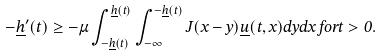Convert formula to latex. <formula><loc_0><loc_0><loc_500><loc_500>- \underline { h } ^ { \prime } ( t ) \geq - \mu \int _ { - \underline { h } ( t ) } ^ { \underline { h } ( t ) } \int _ { - \infty } ^ { - \underline { h } ( t ) } J ( x - y ) \underline { u } ( t , x ) d y d x \, f o r t > 0 .</formula> 